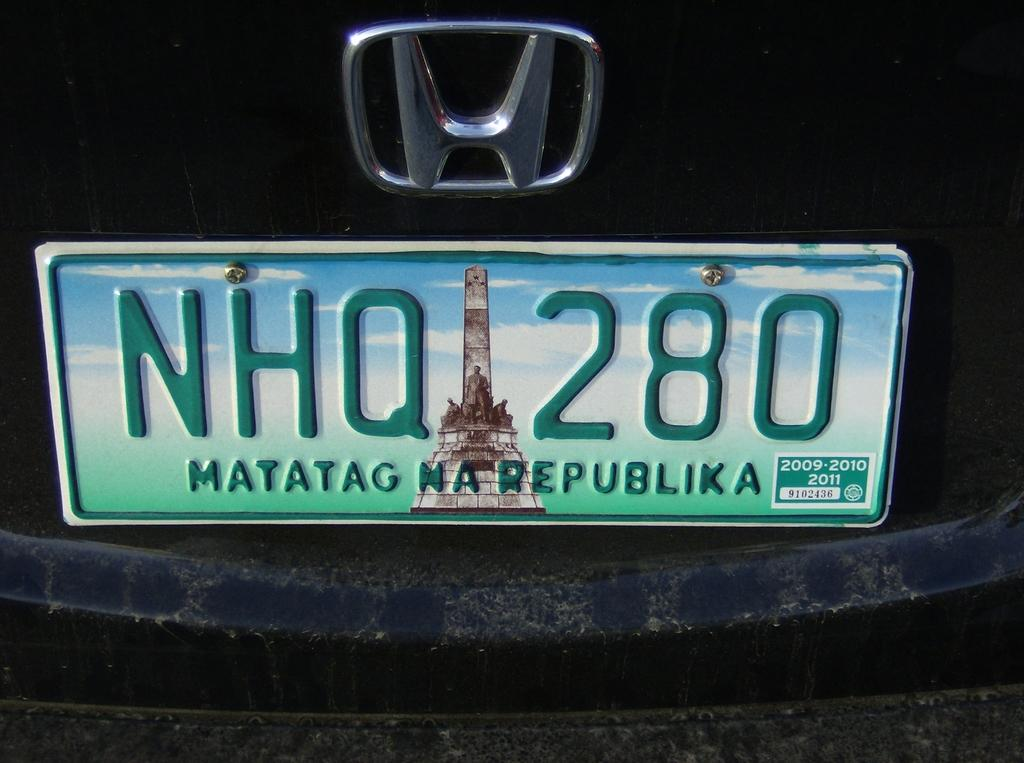<image>
Create a compact narrative representing the image presented. A Honda vehicle displays a front license plate from Matatag Na Republika. 